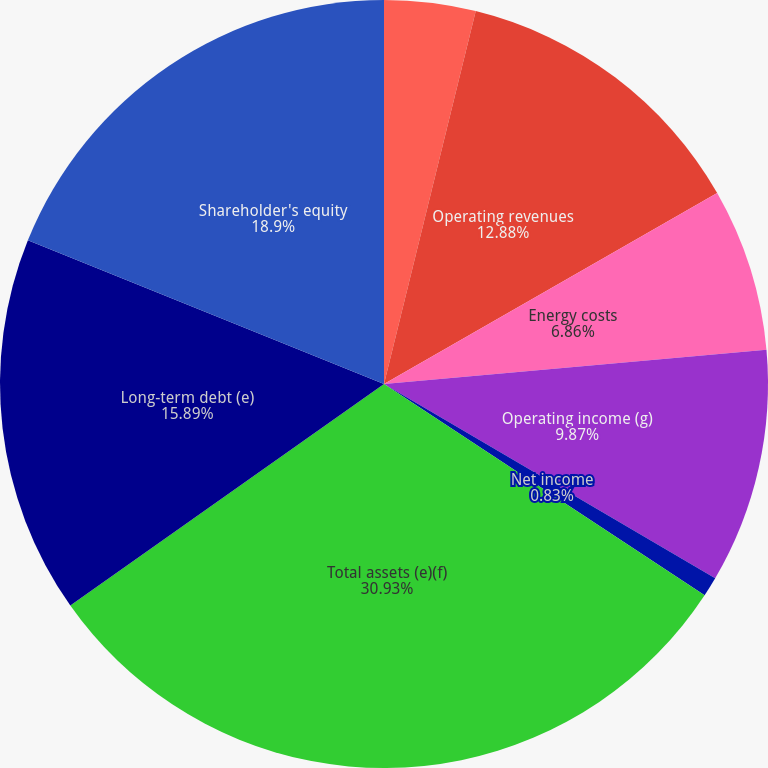Convert chart to OTSL. <chart><loc_0><loc_0><loc_500><loc_500><pie_chart><fcel>(Millions of Dollars)<fcel>Operating revenues<fcel>Energy costs<fcel>Operating income (g)<fcel>Net income<fcel>Total assets (e)(f)<fcel>Long-term debt (e)<fcel>Shareholder's equity<nl><fcel>3.84%<fcel>12.88%<fcel>6.86%<fcel>9.87%<fcel>0.83%<fcel>30.94%<fcel>15.89%<fcel>18.9%<nl></chart> 